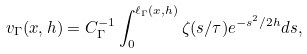Convert formula to latex. <formula><loc_0><loc_0><loc_500><loc_500>v _ { \Gamma } ( x , h ) = C _ { \Gamma } ^ { - 1 } \int _ { 0 } ^ { \ell _ { \Gamma } ( x , h ) } \zeta ( s / \tau ) e ^ { - s ^ { 2 } / 2 h } d s ,</formula> 